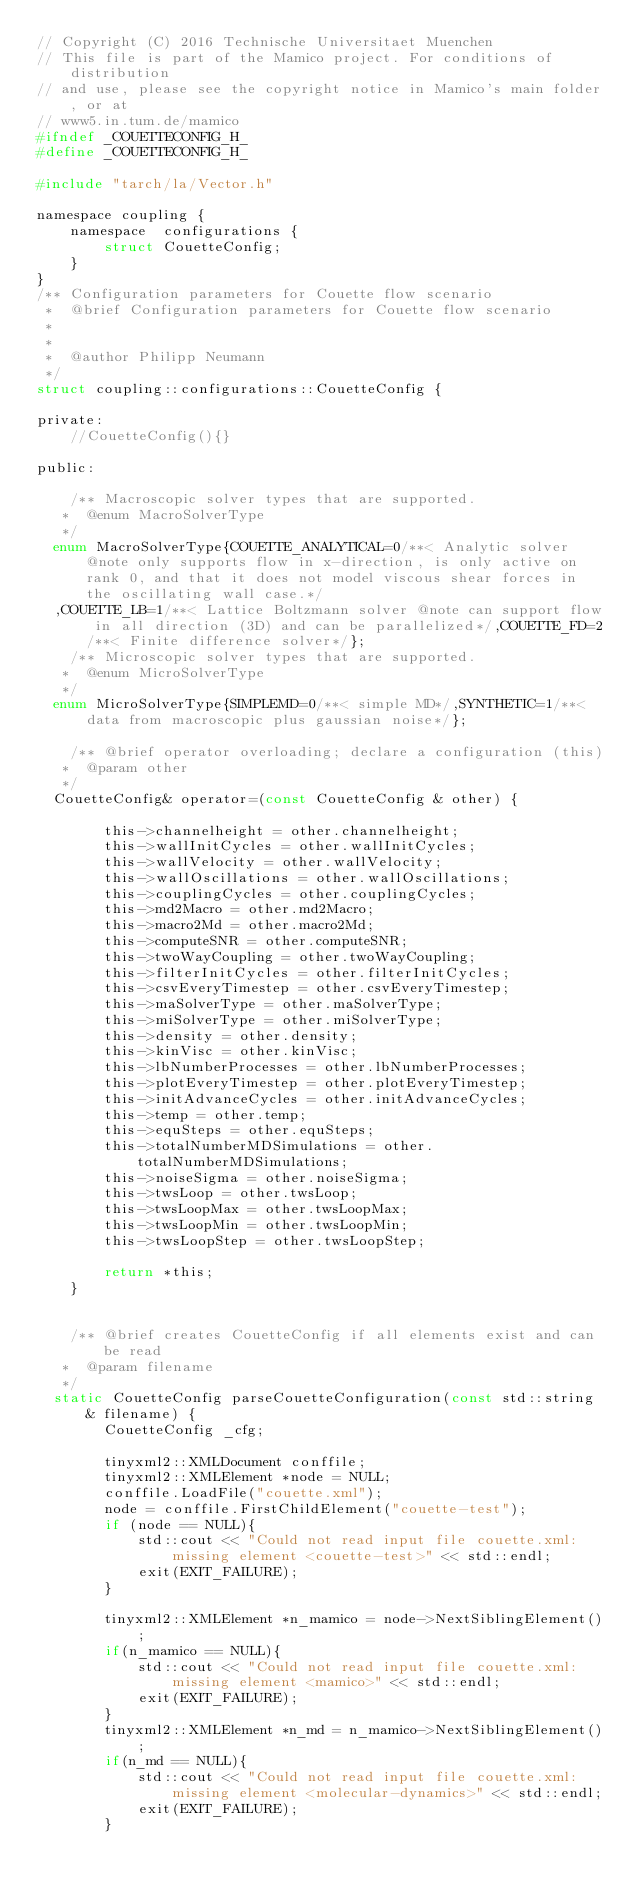<code> <loc_0><loc_0><loc_500><loc_500><_C_>// Copyright (C) 2016 Technische Universitaet Muenchen
// This file is part of the Mamico project. For conditions of distribution
// and use, please see the copyright notice in Mamico's main folder, or at
// www5.in.tum.de/mamico
#ifndef _COUETTECONFIG_H_
#define _COUETTECONFIG_H_

#include "tarch/la/Vector.h"

namespace coupling {
    namespace  configurations {
        struct CouetteConfig;
    }
}
/** Configuration parameters for Couette flow scenario
 *	@brief Configuration parameters for Couette flow scenario
 *	
 *
 *	@author Philipp Neumann
 */
struct coupling::configurations::CouetteConfig {

private:
    //CouetteConfig(){}

public:

    /** Macroscopic solver types that are supported. 
	 *	@enum MacroSolverType
	 */
	enum MacroSolverType{COUETTE_ANALYTICAL=0/**< Analytic solver @note only supports flow in x-direction, is only active on rank 0, and that it does not model viscous shear forces in the oscillating wall case.*/
	,COUETTE_LB=1/**< Lattice Boltzmann solver @note can support flow in all direction (3D) and can be parallelized*/,COUETTE_FD=2/**< Finite difference solver*/};
    /** Microscopic solver types that are supported. 
	 *	@enum MicroSolverType
	 */
	enum MicroSolverType{SIMPLEMD=0/**< simple MD*/,SYNTHETIC=1/**< data from macroscopic plus gaussian noise*/};

    /** @brief operator overloading; declare a configuration (this)
	 * 	@param other
	 */
	CouetteConfig& operator=(const CouetteConfig & other) {

        this->channelheight = other.channelheight;
        this->wallInitCycles = other.wallInitCycles;
        this->wallVelocity = other.wallVelocity;
        this->wallOscillations = other.wallOscillations;
        this->couplingCycles = other.couplingCycles;
        this->md2Macro = other.md2Macro;
        this->macro2Md = other.macro2Md;
        this->computeSNR = other.computeSNR;
        this->twoWayCoupling = other.twoWayCoupling;
        this->filterInitCycles = other.filterInitCycles;
        this->csvEveryTimestep = other.csvEveryTimestep;
        this->maSolverType = other.maSolverType;
        this->miSolverType = other.miSolverType;
        this->density = other.density;
        this->kinVisc = other.kinVisc;
        this->lbNumberProcesses = other.lbNumberProcesses;
        this->plotEveryTimestep = other.plotEveryTimestep;
        this->initAdvanceCycles = other.initAdvanceCycles;
        this->temp = other.temp;
        this->equSteps = other.equSteps;
        this->totalNumberMDSimulations = other.totalNumberMDSimulations;
        this->noiseSigma = other.noiseSigma;
        this->twsLoop = other.twsLoop;
        this->twsLoopMax = other.twsLoopMax;
        this->twsLoopMin = other.twsLoopMin;
        this->twsLoopStep = other.twsLoopStep;

        return *this;
    }
    

    /** @brief creates CouetteConfig if all elements exist and can be read
	 * 	@param filename
	 */
	static CouetteConfig parseCouetteConfiguration(const std::string & filename) {
        CouetteConfig _cfg;

        tinyxml2::XMLDocument conffile;
        tinyxml2::XMLElement *node = NULL;
        conffile.LoadFile("couette.xml");
        node = conffile.FirstChildElement("couette-test");
        if (node == NULL){
            std::cout << "Could not read input file couette.xml: missing element <couette-test>" << std::endl;
            exit(EXIT_FAILURE);
        }

        tinyxml2::XMLElement *n_mamico = node->NextSiblingElement();
        if(n_mamico == NULL){
            std::cout << "Could not read input file couette.xml: missing element <mamico>" << std::endl;
            exit(EXIT_FAILURE);
        }
        tinyxml2::XMLElement *n_md = n_mamico->NextSiblingElement();
        if(n_md == NULL){
            std::cout << "Could not read input file couette.xml: missing element <molecular-dynamics>" << std::endl;
            exit(EXIT_FAILURE);
        }</code> 